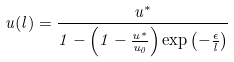Convert formula to latex. <formula><loc_0><loc_0><loc_500><loc_500>u ( l ) = \frac { u ^ { * } } { 1 - \left ( 1 - \frac { u ^ { * } } { u _ { 0 } } \right ) \exp \left ( - \frac { \epsilon } { l } \right ) }</formula> 